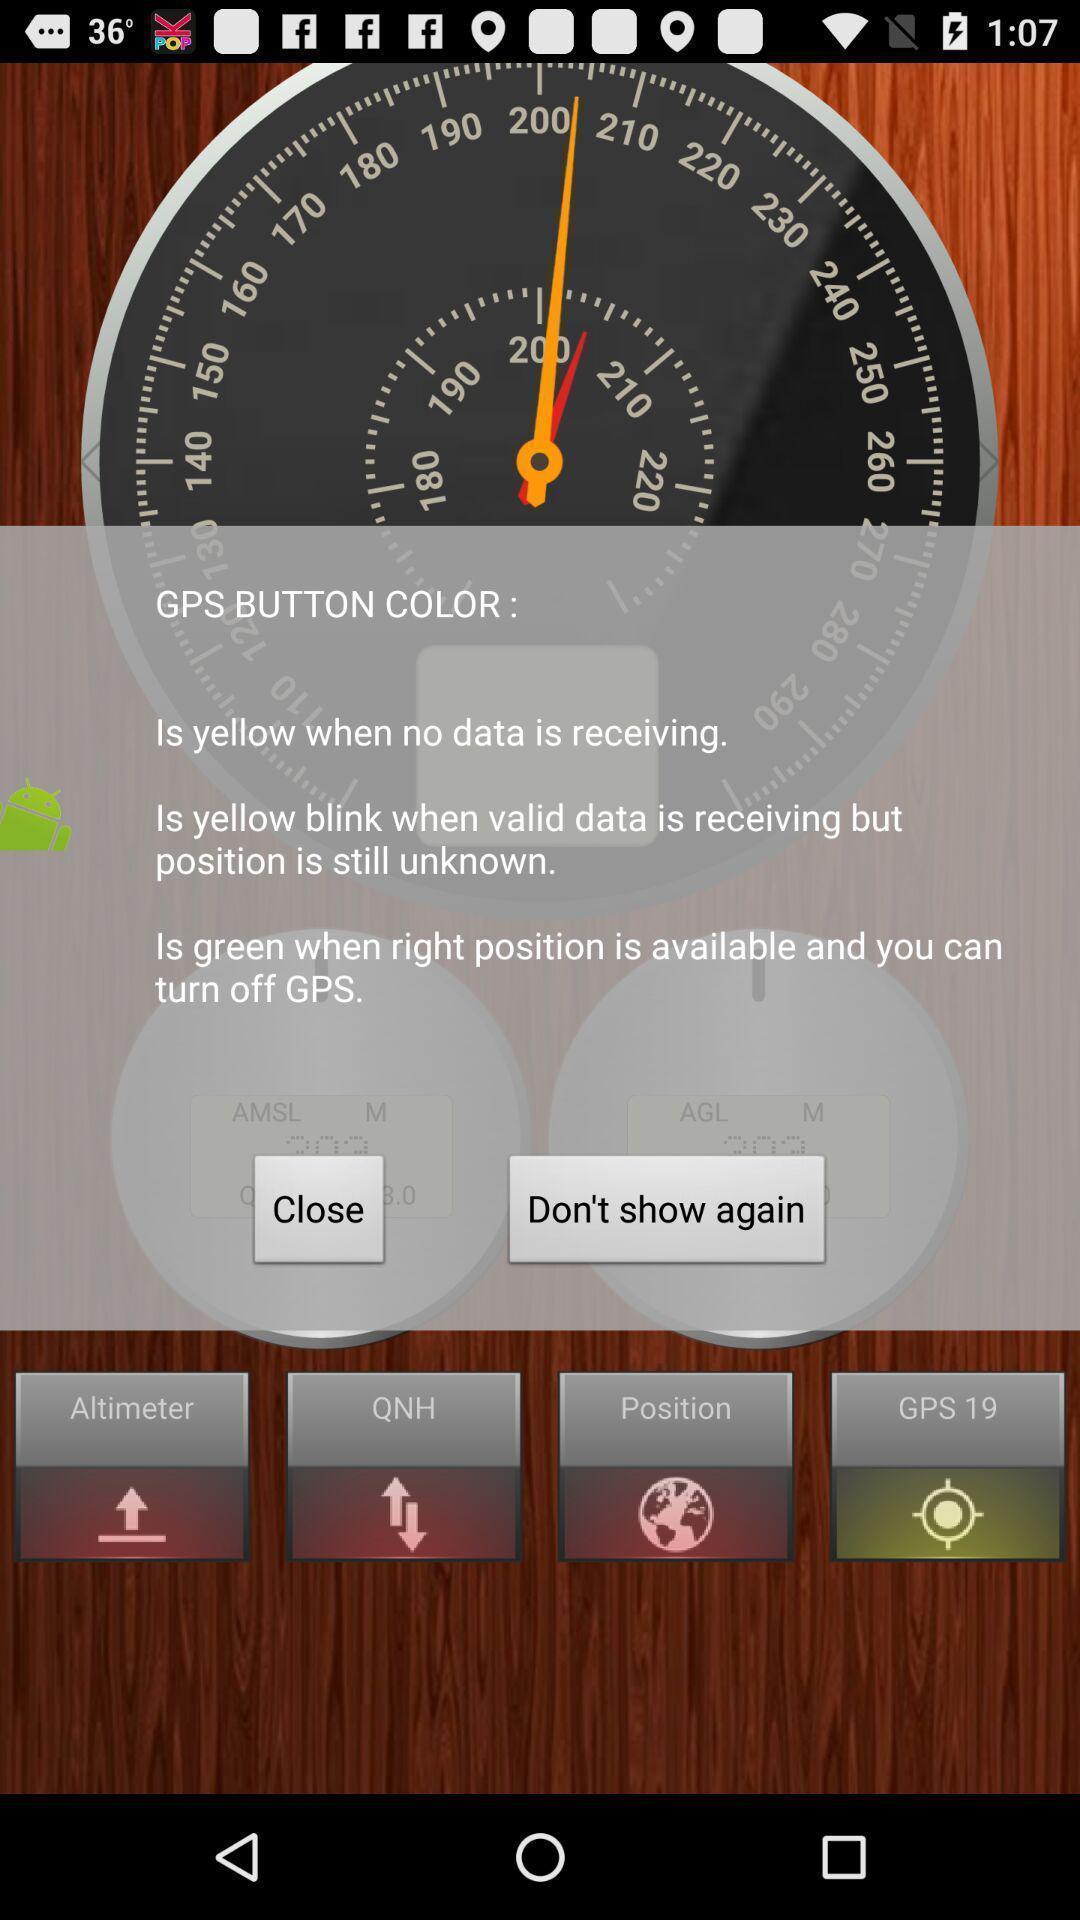Please provide a description for this image. Screen displaying pop-up message about gps. 